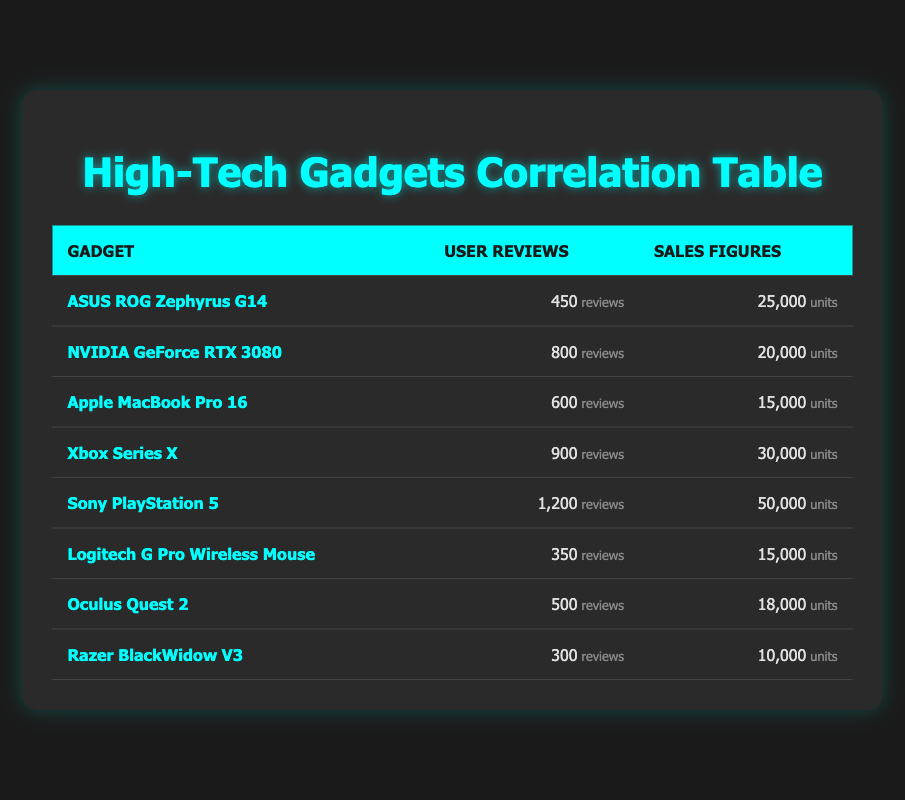How many user reviews does the Sony PlayStation 5 have? The Sony PlayStation 5 row shows that it has 1,200 user reviews listed in the table.
Answer: 1,200 What are the sales figures for the ASUS ROG Zephyrus G14? The sales figures row for the ASUS ROG Zephyrus G14 indicate that it sold 25,000 units.
Answer: 25,000 Which gadget has the highest user reviews and sales figures? The Sony PlayStation 5 has the highest user reviews (1,200) and sales figures (50,000), as indicated in the table.
Answer: Sony PlayStation 5 What is the average number of user reviews across all gadgets? To calculate the average, sum the user reviews: 450 + 800 + 600 + 900 + 1200 + 350 + 500 + 300 = 4,100. There are 8 gadgets, so the average is 4,100 / 8 = 512.5.
Answer: 512.5 Is there a gadget with sales figures below 15,000? Yes, both the Apple MacBook Pro 16 and the Razer BlackWidow V3 have sales figures of 15,000 or below, as shown in the table.
Answer: Yes Which gadget has the lowest sales figures? The Razer BlackWidow V3 has the lowest sales figures, listed as 10,000 units in the table.
Answer: Razer BlackWidow V3 What is the total number of user reviews for all gadgets that have sales figures over 20,000? The gadgets with sales figures over 20,000 are the Xbox Series X, Sony PlayStation 5, and ASUS ROG Zephyrus G14. Summing their user reviews: 900 + 1,200 + 450 = 2,550.
Answer: 2,550 Is the NVIDIA GeForce RTX 3080 among the top three gadgets in sales figures and user reviews? The NVIDIA GeForce RTX 3080 has 800 user reviews and 20,000 sales figures which does not rank it in the top three for either category when compared to the others in the table.
Answer: No 